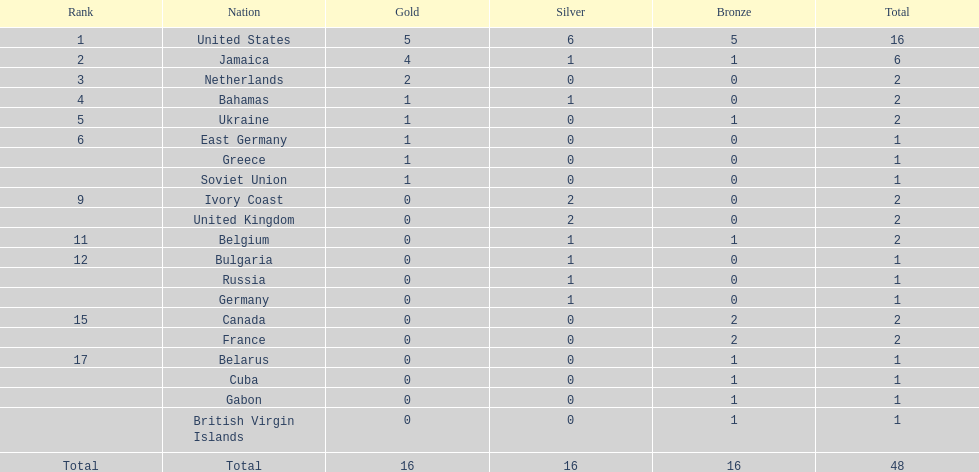How many nations received more medals than canada? 2. 